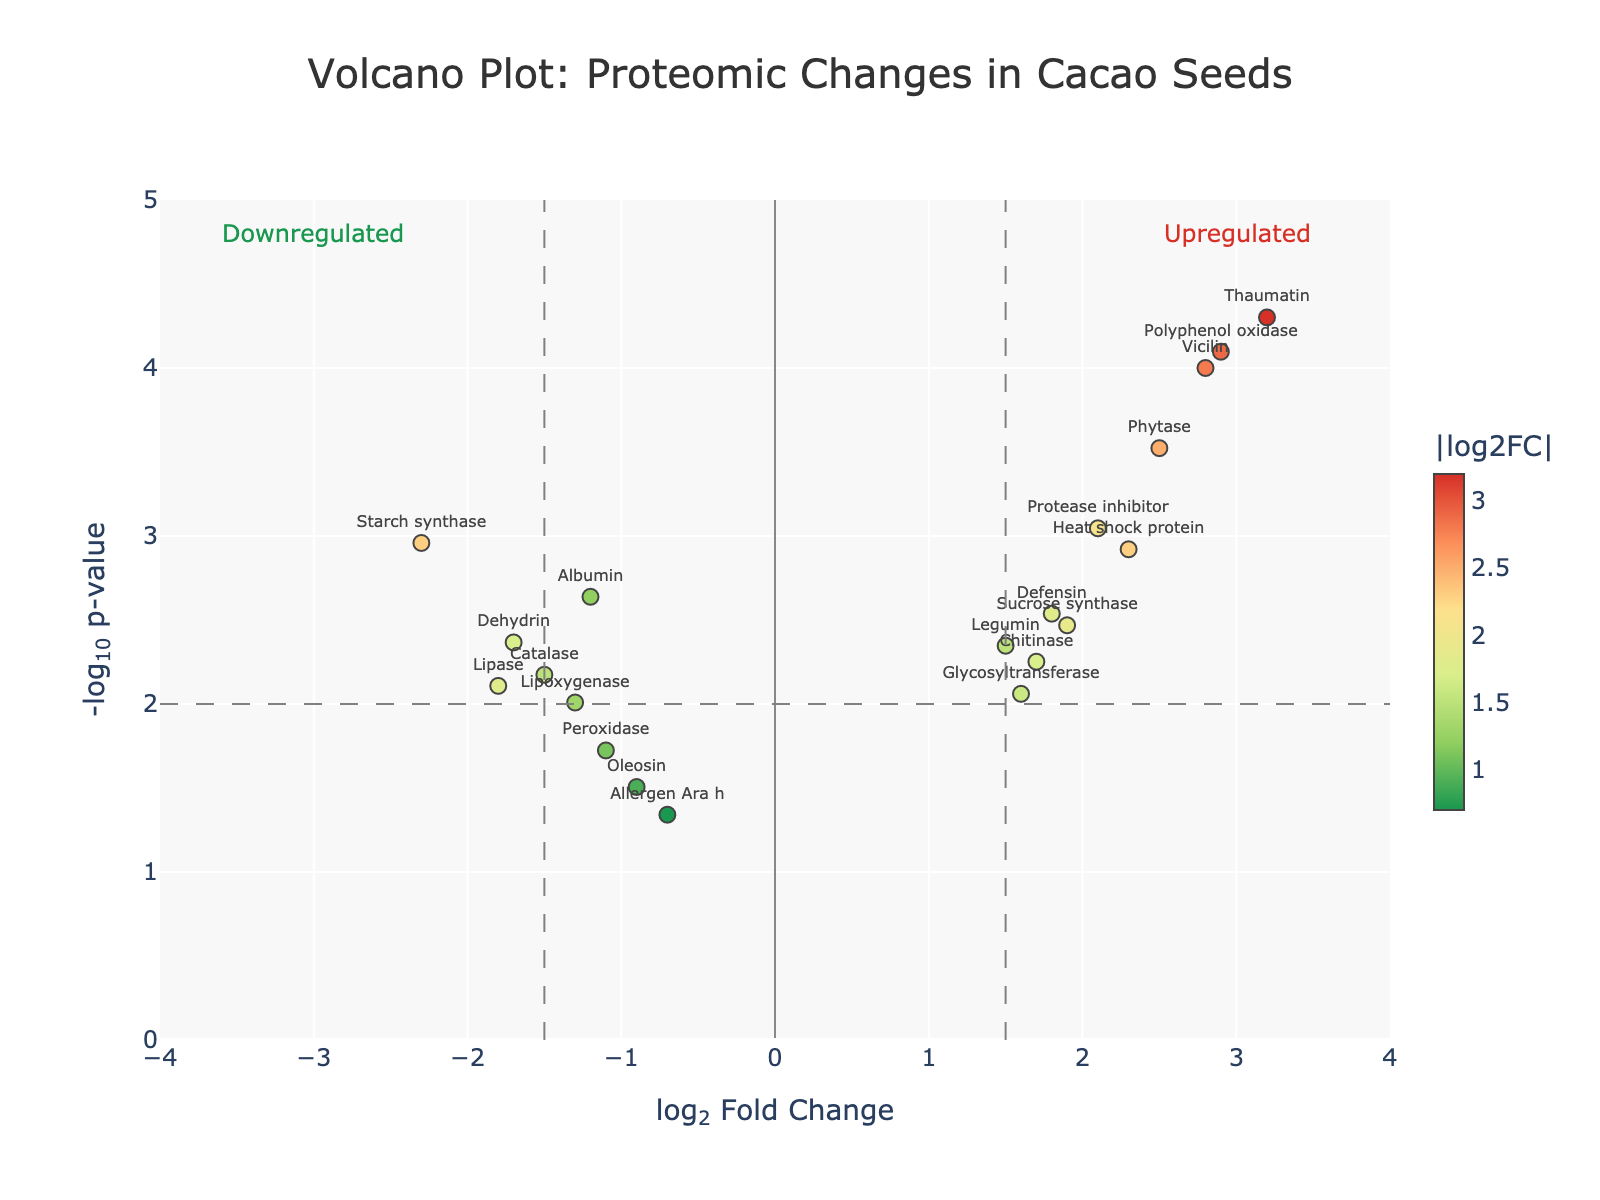What is the title of the plot? The title of the plot is located at the top of the figure.
Answer: Volcano Plot: Proteomic Changes in Cacao Seeds Which protein has the highest -log10(p-value)? To find this, look for the point with the highest y-value on the plot. The protein indicated is "Thaumatin".
Answer: Thaumatin How many proteins have a log2FoldChange greater than 2? Identify the markers on the right side of the vertical line at x = 2. The proteins are "Vicilin", "Thaumatin", "Polyphenol oxidase", and "Heat shock protein". Count them.
Answer: 4 Which protein shows the most significant downregulation? Downregulated proteins are those with negative log2FoldChanges. Identify the protein with the lowest x-value. "Starch synthase" has the lowest log2FoldChange.
Answer: Starch synthase What is the log2FoldChange and p-value of Vicilin? Hover over the point labeled "Vicilin" to read the hovertext that has these values. The hovertext shows "log2FC: 2.80", "p-value: 0.0001".
Answer: log2FoldChange: 2.80, p-value: 0.0001 Are more proteins upregulated or downregulated with a p-value less than 0.01? Count the number of proteins with p-values below 0.01 (above y ≈ 2) that are on the positive and negative sides of the x-axis. There are more upregulated proteins as there are 8 points on the right side of the plot above the line and 6 on the left.
Answer: Upregulated What does the horizontal dashed line represent? The horizontal dashed line represents the p-value significance threshold of 0.01. The line is at y = -log10(0.01) which equates to y ≈ 2.
Answer: Significance threshold p-value of 0.01 Which two proteins are the most similarly regulated with log2FoldChange and -log10(p-value) close to each other? Inspect the plot and identify two points close together. "Defensin" and "Sucrose synthase" are very close with "log2FC: 1.8, p-value: 0.0029" and "log2FC: 1.9, p-value: 0.0034" respectively.
Answer: Defensin and Sucrose synthase 